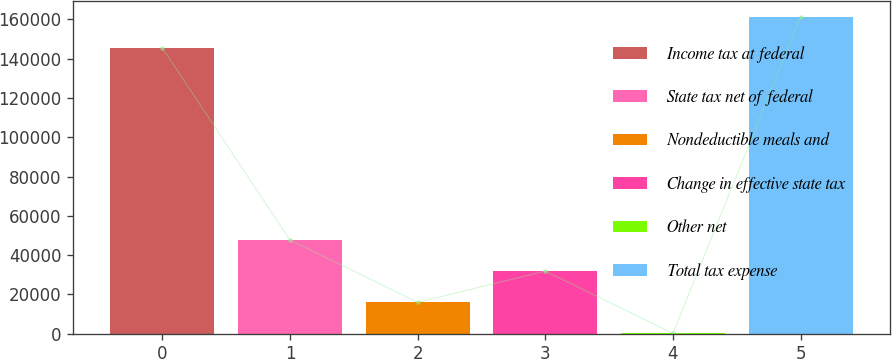<chart> <loc_0><loc_0><loc_500><loc_500><bar_chart><fcel>Income tax at federal<fcel>State tax net of federal<fcel>Nondeductible meals and<fcel>Change in effective state tax<fcel>Other net<fcel>Total tax expense<nl><fcel>145506<fcel>47744.1<fcel>16034.7<fcel>31889.4<fcel>180<fcel>161361<nl></chart> 